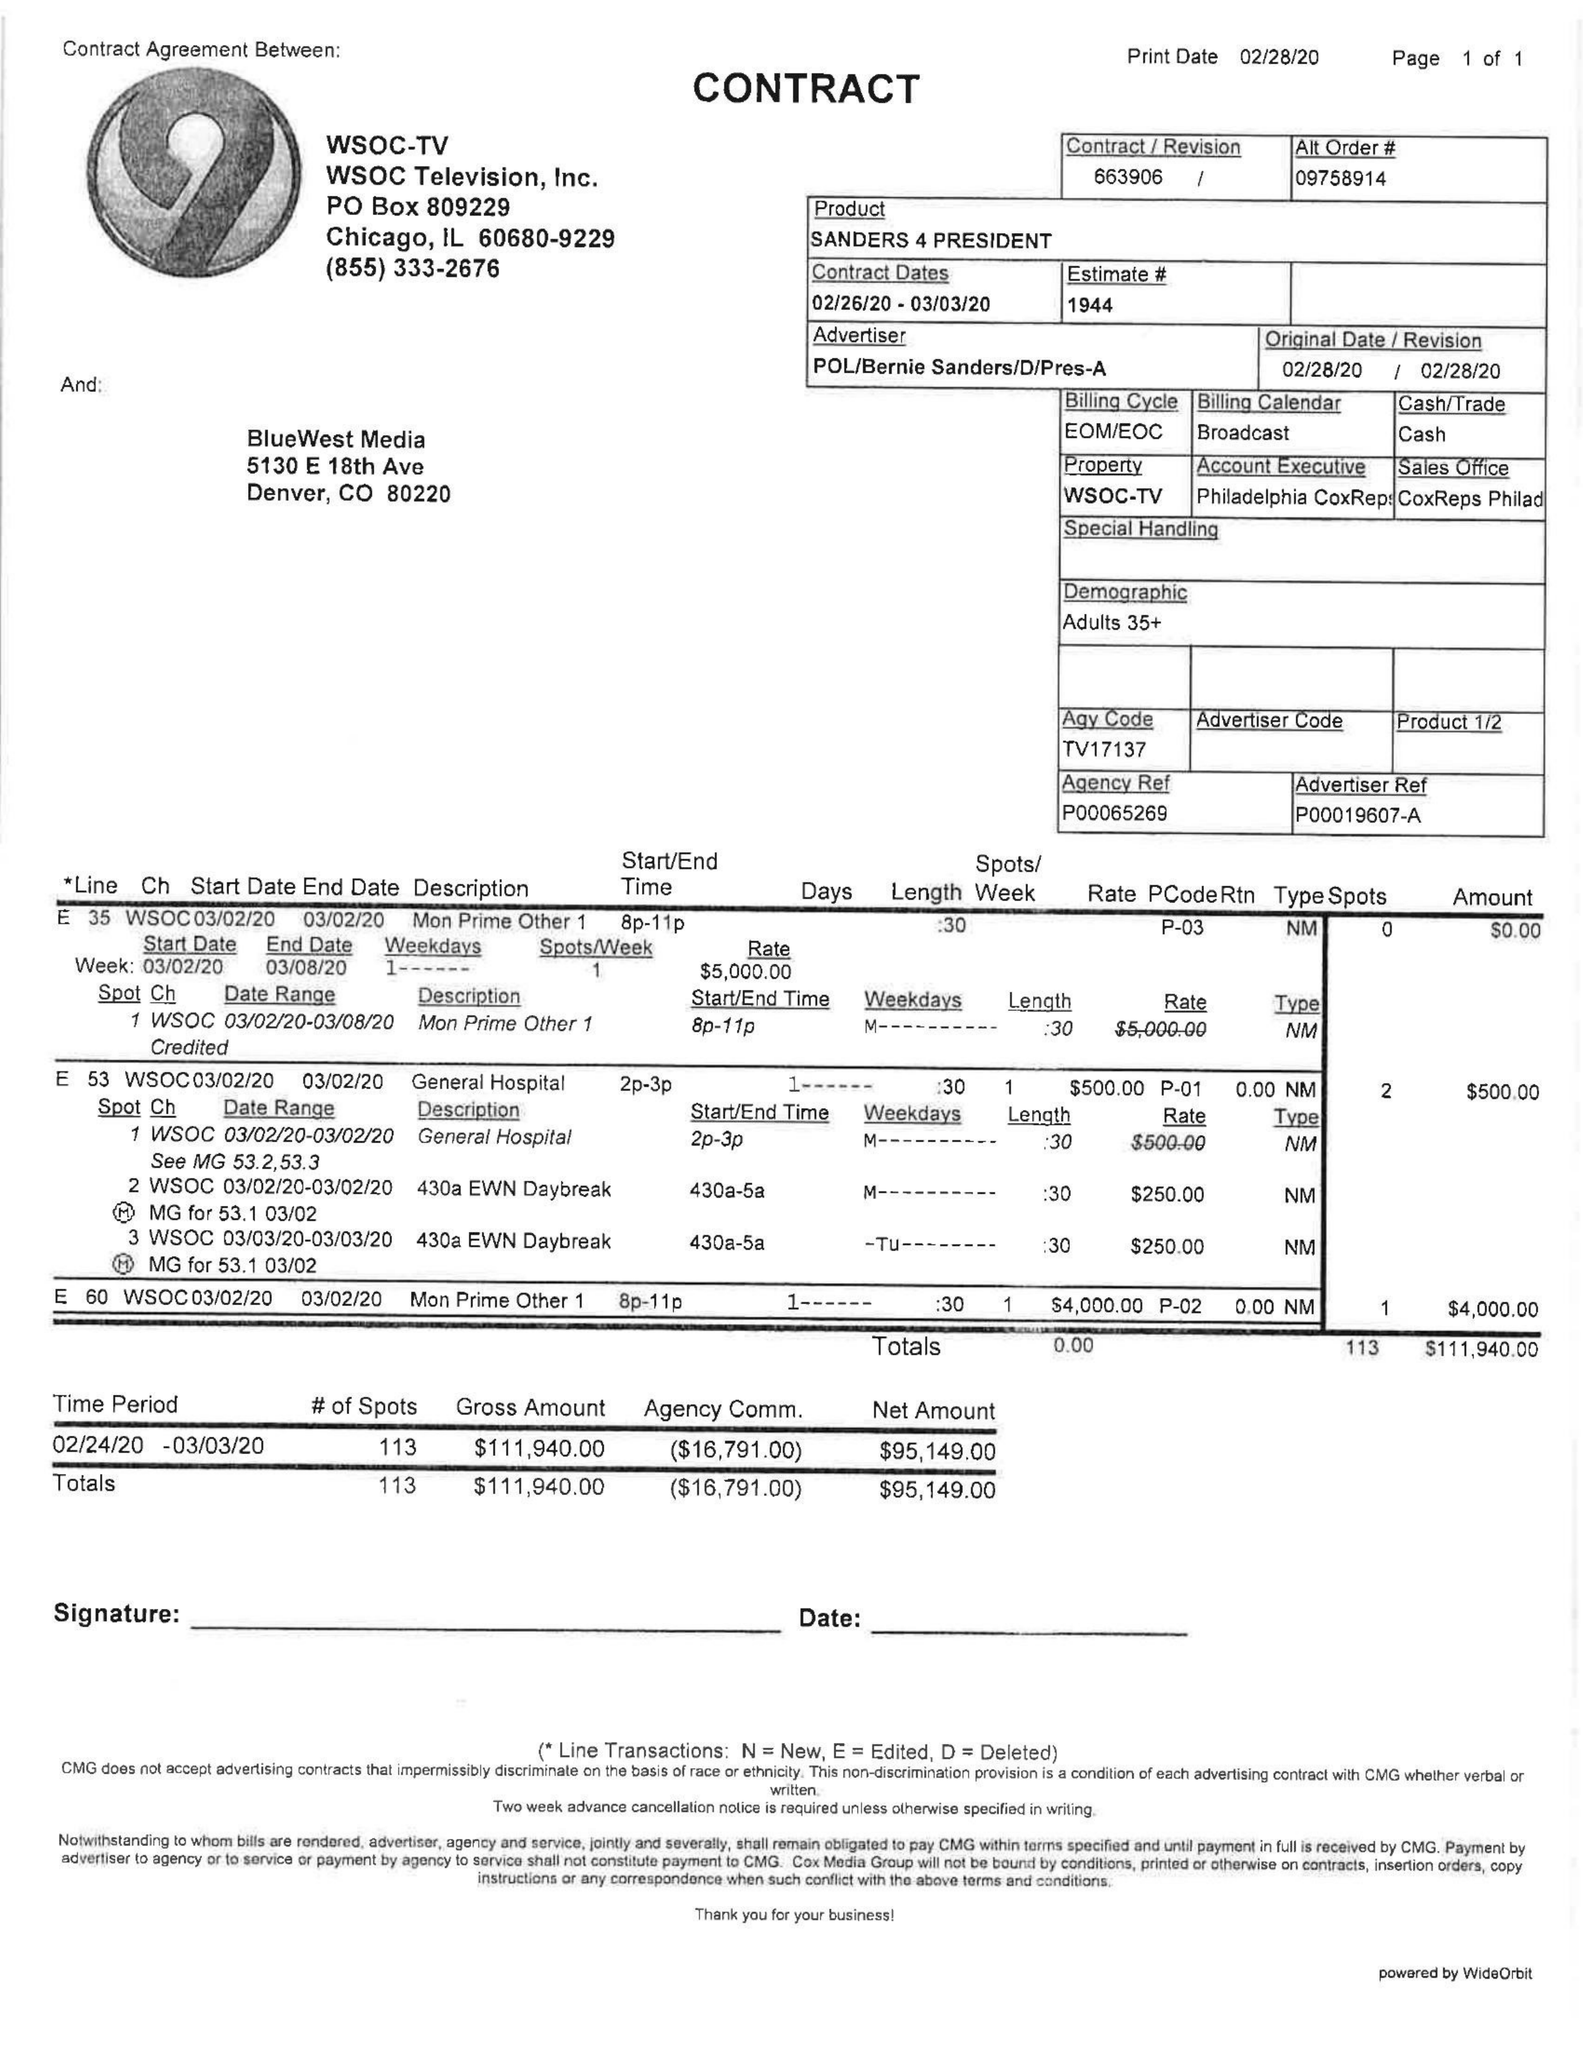What is the value for the flight_from?
Answer the question using a single word or phrase. 02/26/20 